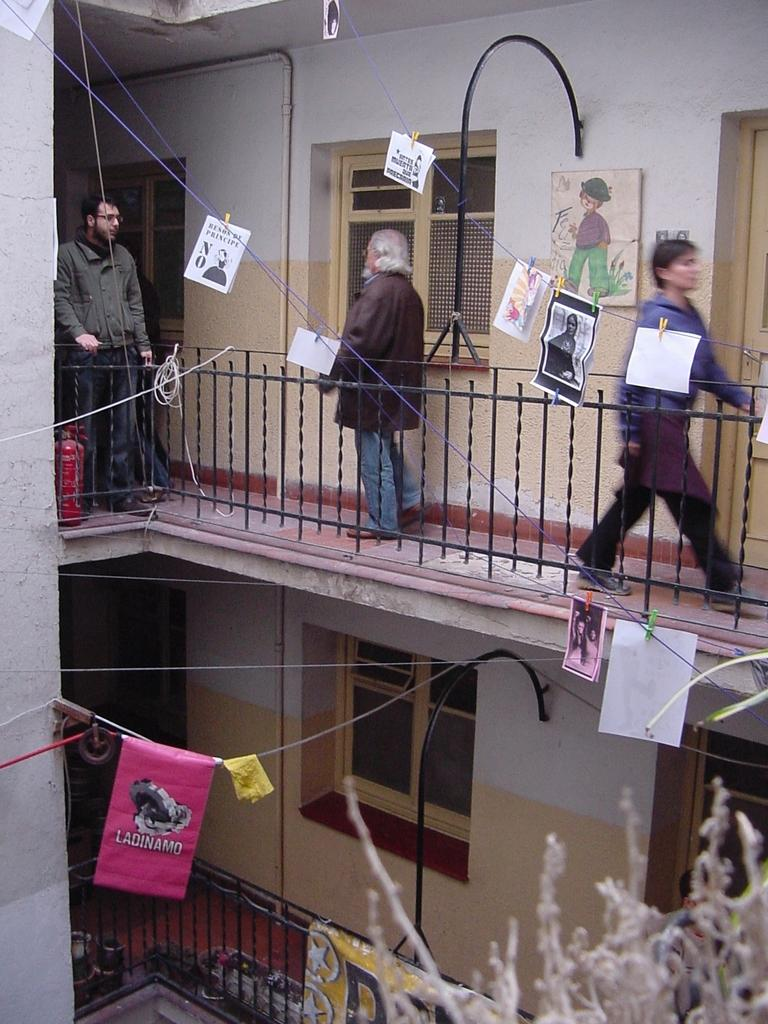What are the people in the image doing? Some people are walking, and some are standing in the image. What can be seen on the people in the image? The people are wearing clothes. What structures are present in the image? There is a fence, a poster, a window, and a door in the image. What natural elements can be seen in the image? Tree branches are visible in the image. What type of scent can be detected from the poster in the image? There is no indication of a scent associated with the poster in the image. What activity are the people participating in together in the image? The image does not show the people participating in a specific activity together; they are simply walking or standing. 